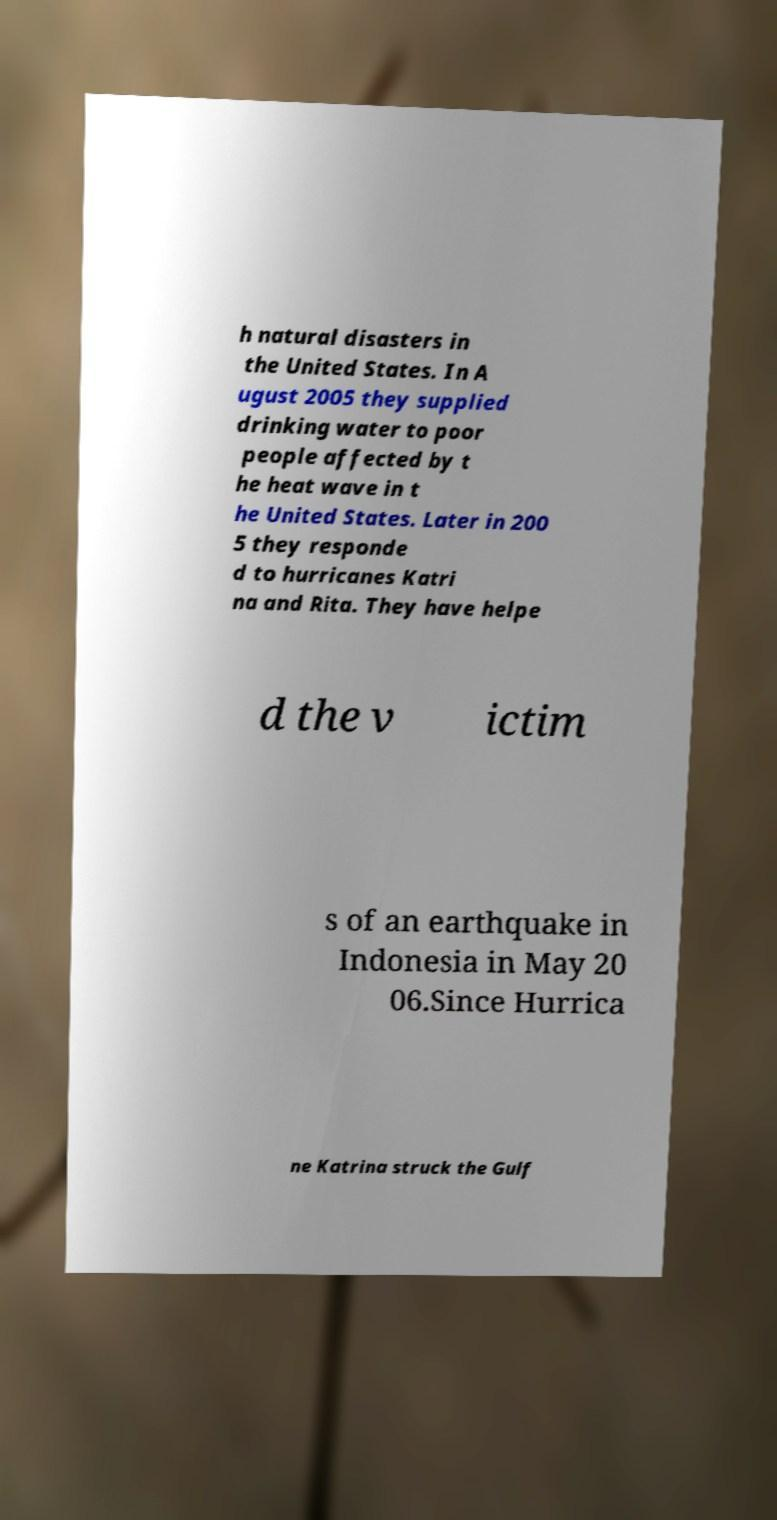I need the written content from this picture converted into text. Can you do that? h natural disasters in the United States. In A ugust 2005 they supplied drinking water to poor people affected by t he heat wave in t he United States. Later in 200 5 they responde d to hurricanes Katri na and Rita. They have helpe d the v ictim s of an earthquake in Indonesia in May 20 06.Since Hurrica ne Katrina struck the Gulf 